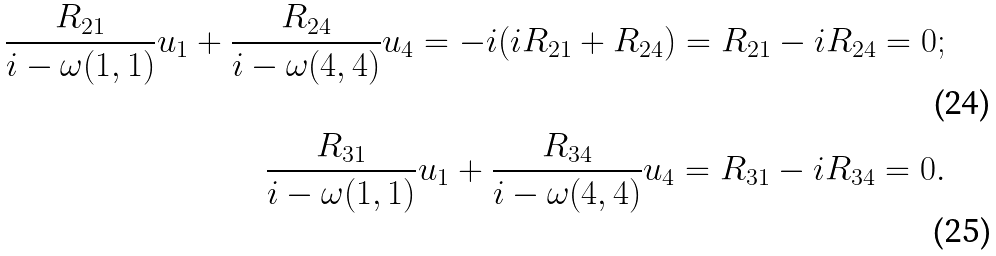<formula> <loc_0><loc_0><loc_500><loc_500>\frac { R _ { 2 1 } } { i - \omega ( 1 , 1 ) } u _ { 1 } + \frac { R _ { 2 4 } } { i - \omega ( 4 , 4 ) } u _ { 4 } = - i ( i R _ { 2 1 } + R _ { 2 4 } ) = R _ { 2 1 } - i R _ { 2 4 } = 0 ; \\ \frac { R _ { 3 1 } } { i - \omega ( 1 , 1 ) } u _ { 1 } + \frac { R _ { 3 4 } } { i - \omega ( 4 , 4 ) } u _ { 4 } = R _ { 3 1 } - i R _ { 3 4 } = 0 .</formula> 